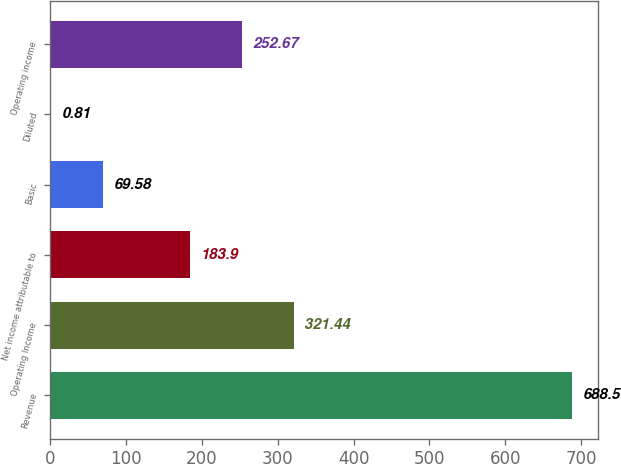<chart> <loc_0><loc_0><loc_500><loc_500><bar_chart><fcel>Revenue<fcel>Operating Income<fcel>Net income attributable to<fcel>Basic<fcel>Diluted<fcel>Operating income<nl><fcel>688.5<fcel>321.44<fcel>183.9<fcel>69.58<fcel>0.81<fcel>252.67<nl></chart> 